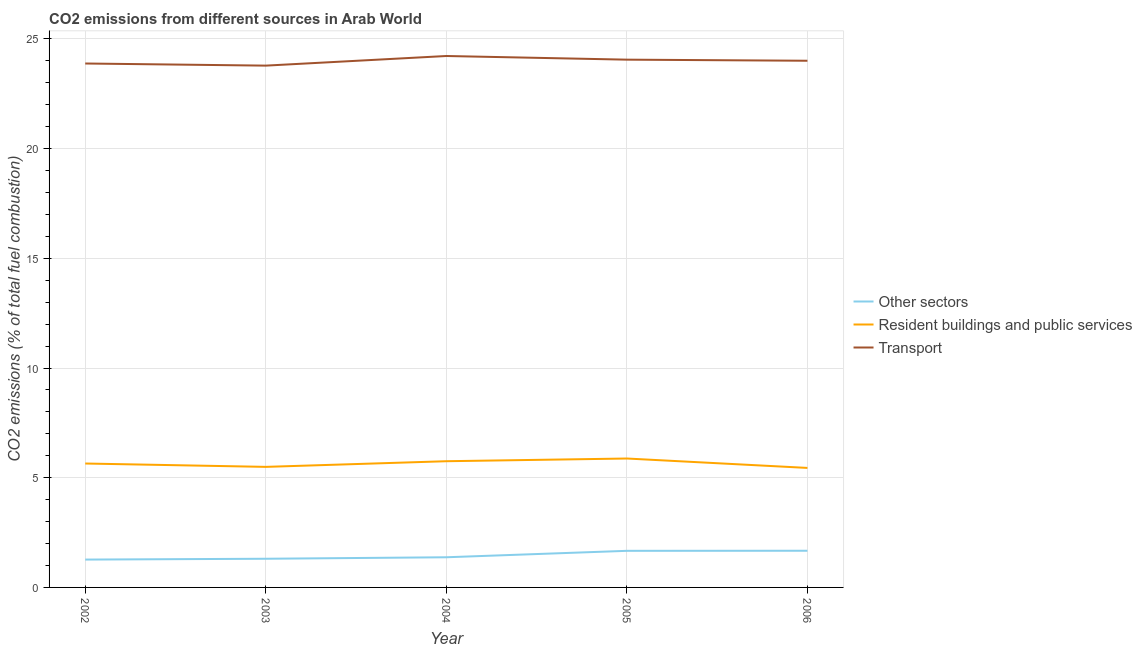How many different coloured lines are there?
Your response must be concise. 3. Does the line corresponding to percentage of co2 emissions from transport intersect with the line corresponding to percentage of co2 emissions from resident buildings and public services?
Your response must be concise. No. Is the number of lines equal to the number of legend labels?
Offer a very short reply. Yes. What is the percentage of co2 emissions from transport in 2002?
Ensure brevity in your answer.  23.88. Across all years, what is the maximum percentage of co2 emissions from resident buildings and public services?
Provide a short and direct response. 5.88. Across all years, what is the minimum percentage of co2 emissions from transport?
Give a very brief answer. 23.79. What is the total percentage of co2 emissions from other sectors in the graph?
Your answer should be very brief. 7.29. What is the difference between the percentage of co2 emissions from transport in 2003 and that in 2004?
Provide a short and direct response. -0.44. What is the difference between the percentage of co2 emissions from resident buildings and public services in 2006 and the percentage of co2 emissions from other sectors in 2004?
Your answer should be very brief. 4.07. What is the average percentage of co2 emissions from resident buildings and public services per year?
Ensure brevity in your answer.  5.64. In the year 2003, what is the difference between the percentage of co2 emissions from transport and percentage of co2 emissions from resident buildings and public services?
Your response must be concise. 18.29. In how many years, is the percentage of co2 emissions from transport greater than 10 %?
Your response must be concise. 5. What is the ratio of the percentage of co2 emissions from other sectors in 2005 to that in 2006?
Your answer should be compact. 1. What is the difference between the highest and the second highest percentage of co2 emissions from other sectors?
Your answer should be compact. 0. What is the difference between the highest and the lowest percentage of co2 emissions from other sectors?
Keep it short and to the point. 0.4. In how many years, is the percentage of co2 emissions from other sectors greater than the average percentage of co2 emissions from other sectors taken over all years?
Your answer should be very brief. 2. Is the sum of the percentage of co2 emissions from other sectors in 2004 and 2005 greater than the maximum percentage of co2 emissions from resident buildings and public services across all years?
Ensure brevity in your answer.  No. Is it the case that in every year, the sum of the percentage of co2 emissions from other sectors and percentage of co2 emissions from resident buildings and public services is greater than the percentage of co2 emissions from transport?
Offer a terse response. No. Does the percentage of co2 emissions from other sectors monotonically increase over the years?
Ensure brevity in your answer.  Yes. Is the percentage of co2 emissions from resident buildings and public services strictly greater than the percentage of co2 emissions from other sectors over the years?
Keep it short and to the point. Yes. Is the percentage of co2 emissions from transport strictly less than the percentage of co2 emissions from other sectors over the years?
Keep it short and to the point. No. How many lines are there?
Provide a short and direct response. 3. How many years are there in the graph?
Give a very brief answer. 5. What is the difference between two consecutive major ticks on the Y-axis?
Provide a succinct answer. 5. Are the values on the major ticks of Y-axis written in scientific E-notation?
Your answer should be compact. No. Does the graph contain any zero values?
Keep it short and to the point. No. Does the graph contain grids?
Make the answer very short. Yes. How many legend labels are there?
Offer a terse response. 3. How are the legend labels stacked?
Your answer should be compact. Vertical. What is the title of the graph?
Your answer should be very brief. CO2 emissions from different sources in Arab World. What is the label or title of the X-axis?
Your answer should be compact. Year. What is the label or title of the Y-axis?
Your response must be concise. CO2 emissions (% of total fuel combustion). What is the CO2 emissions (% of total fuel combustion) of Other sectors in 2002?
Offer a very short reply. 1.27. What is the CO2 emissions (% of total fuel combustion) of Resident buildings and public services in 2002?
Ensure brevity in your answer.  5.65. What is the CO2 emissions (% of total fuel combustion) of Transport in 2002?
Offer a terse response. 23.88. What is the CO2 emissions (% of total fuel combustion) in Other sectors in 2003?
Provide a succinct answer. 1.31. What is the CO2 emissions (% of total fuel combustion) in Resident buildings and public services in 2003?
Your answer should be very brief. 5.5. What is the CO2 emissions (% of total fuel combustion) in Transport in 2003?
Make the answer very short. 23.79. What is the CO2 emissions (% of total fuel combustion) of Other sectors in 2004?
Your response must be concise. 1.38. What is the CO2 emissions (% of total fuel combustion) in Resident buildings and public services in 2004?
Offer a very short reply. 5.75. What is the CO2 emissions (% of total fuel combustion) in Transport in 2004?
Offer a terse response. 24.22. What is the CO2 emissions (% of total fuel combustion) in Other sectors in 2005?
Give a very brief answer. 1.67. What is the CO2 emissions (% of total fuel combustion) of Resident buildings and public services in 2005?
Ensure brevity in your answer.  5.88. What is the CO2 emissions (% of total fuel combustion) of Transport in 2005?
Give a very brief answer. 24.06. What is the CO2 emissions (% of total fuel combustion) in Other sectors in 2006?
Ensure brevity in your answer.  1.67. What is the CO2 emissions (% of total fuel combustion) in Resident buildings and public services in 2006?
Give a very brief answer. 5.45. What is the CO2 emissions (% of total fuel combustion) of Transport in 2006?
Your response must be concise. 24.01. Across all years, what is the maximum CO2 emissions (% of total fuel combustion) of Other sectors?
Your answer should be very brief. 1.67. Across all years, what is the maximum CO2 emissions (% of total fuel combustion) in Resident buildings and public services?
Provide a short and direct response. 5.88. Across all years, what is the maximum CO2 emissions (% of total fuel combustion) of Transport?
Your response must be concise. 24.22. Across all years, what is the minimum CO2 emissions (% of total fuel combustion) in Other sectors?
Offer a very short reply. 1.27. Across all years, what is the minimum CO2 emissions (% of total fuel combustion) in Resident buildings and public services?
Provide a succinct answer. 5.45. Across all years, what is the minimum CO2 emissions (% of total fuel combustion) in Transport?
Provide a succinct answer. 23.79. What is the total CO2 emissions (% of total fuel combustion) of Other sectors in the graph?
Your answer should be compact. 7.29. What is the total CO2 emissions (% of total fuel combustion) in Resident buildings and public services in the graph?
Keep it short and to the point. 28.22. What is the total CO2 emissions (% of total fuel combustion) of Transport in the graph?
Offer a terse response. 119.96. What is the difference between the CO2 emissions (% of total fuel combustion) of Other sectors in 2002 and that in 2003?
Your answer should be very brief. -0.04. What is the difference between the CO2 emissions (% of total fuel combustion) in Resident buildings and public services in 2002 and that in 2003?
Offer a terse response. 0.15. What is the difference between the CO2 emissions (% of total fuel combustion) of Transport in 2002 and that in 2003?
Provide a succinct answer. 0.1. What is the difference between the CO2 emissions (% of total fuel combustion) of Other sectors in 2002 and that in 2004?
Make the answer very short. -0.11. What is the difference between the CO2 emissions (% of total fuel combustion) of Resident buildings and public services in 2002 and that in 2004?
Ensure brevity in your answer.  -0.1. What is the difference between the CO2 emissions (% of total fuel combustion) in Transport in 2002 and that in 2004?
Give a very brief answer. -0.34. What is the difference between the CO2 emissions (% of total fuel combustion) in Other sectors in 2002 and that in 2005?
Provide a short and direct response. -0.4. What is the difference between the CO2 emissions (% of total fuel combustion) of Resident buildings and public services in 2002 and that in 2005?
Provide a short and direct response. -0.23. What is the difference between the CO2 emissions (% of total fuel combustion) of Transport in 2002 and that in 2005?
Give a very brief answer. -0.18. What is the difference between the CO2 emissions (% of total fuel combustion) of Other sectors in 2002 and that in 2006?
Keep it short and to the point. -0.4. What is the difference between the CO2 emissions (% of total fuel combustion) of Resident buildings and public services in 2002 and that in 2006?
Your answer should be very brief. 0.2. What is the difference between the CO2 emissions (% of total fuel combustion) in Transport in 2002 and that in 2006?
Offer a very short reply. -0.13. What is the difference between the CO2 emissions (% of total fuel combustion) in Other sectors in 2003 and that in 2004?
Ensure brevity in your answer.  -0.07. What is the difference between the CO2 emissions (% of total fuel combustion) of Resident buildings and public services in 2003 and that in 2004?
Offer a terse response. -0.26. What is the difference between the CO2 emissions (% of total fuel combustion) in Transport in 2003 and that in 2004?
Ensure brevity in your answer.  -0.44. What is the difference between the CO2 emissions (% of total fuel combustion) of Other sectors in 2003 and that in 2005?
Ensure brevity in your answer.  -0.36. What is the difference between the CO2 emissions (% of total fuel combustion) in Resident buildings and public services in 2003 and that in 2005?
Ensure brevity in your answer.  -0.38. What is the difference between the CO2 emissions (% of total fuel combustion) in Transport in 2003 and that in 2005?
Your answer should be very brief. -0.27. What is the difference between the CO2 emissions (% of total fuel combustion) in Other sectors in 2003 and that in 2006?
Your response must be concise. -0.36. What is the difference between the CO2 emissions (% of total fuel combustion) in Resident buildings and public services in 2003 and that in 2006?
Offer a very short reply. 0.05. What is the difference between the CO2 emissions (% of total fuel combustion) of Transport in 2003 and that in 2006?
Your response must be concise. -0.22. What is the difference between the CO2 emissions (% of total fuel combustion) of Other sectors in 2004 and that in 2005?
Provide a succinct answer. -0.29. What is the difference between the CO2 emissions (% of total fuel combustion) in Resident buildings and public services in 2004 and that in 2005?
Give a very brief answer. -0.12. What is the difference between the CO2 emissions (% of total fuel combustion) in Transport in 2004 and that in 2005?
Your response must be concise. 0.17. What is the difference between the CO2 emissions (% of total fuel combustion) of Other sectors in 2004 and that in 2006?
Provide a short and direct response. -0.3. What is the difference between the CO2 emissions (% of total fuel combustion) in Resident buildings and public services in 2004 and that in 2006?
Your answer should be very brief. 0.31. What is the difference between the CO2 emissions (% of total fuel combustion) in Transport in 2004 and that in 2006?
Make the answer very short. 0.22. What is the difference between the CO2 emissions (% of total fuel combustion) in Other sectors in 2005 and that in 2006?
Provide a succinct answer. -0. What is the difference between the CO2 emissions (% of total fuel combustion) of Resident buildings and public services in 2005 and that in 2006?
Your answer should be very brief. 0.43. What is the difference between the CO2 emissions (% of total fuel combustion) in Transport in 2005 and that in 2006?
Give a very brief answer. 0.05. What is the difference between the CO2 emissions (% of total fuel combustion) of Other sectors in 2002 and the CO2 emissions (% of total fuel combustion) of Resident buildings and public services in 2003?
Offer a terse response. -4.23. What is the difference between the CO2 emissions (% of total fuel combustion) of Other sectors in 2002 and the CO2 emissions (% of total fuel combustion) of Transport in 2003?
Keep it short and to the point. -22.52. What is the difference between the CO2 emissions (% of total fuel combustion) in Resident buildings and public services in 2002 and the CO2 emissions (% of total fuel combustion) in Transport in 2003?
Give a very brief answer. -18.14. What is the difference between the CO2 emissions (% of total fuel combustion) in Other sectors in 2002 and the CO2 emissions (% of total fuel combustion) in Resident buildings and public services in 2004?
Your response must be concise. -4.48. What is the difference between the CO2 emissions (% of total fuel combustion) in Other sectors in 2002 and the CO2 emissions (% of total fuel combustion) in Transport in 2004?
Make the answer very short. -22.95. What is the difference between the CO2 emissions (% of total fuel combustion) in Resident buildings and public services in 2002 and the CO2 emissions (% of total fuel combustion) in Transport in 2004?
Ensure brevity in your answer.  -18.58. What is the difference between the CO2 emissions (% of total fuel combustion) of Other sectors in 2002 and the CO2 emissions (% of total fuel combustion) of Resident buildings and public services in 2005?
Provide a succinct answer. -4.61. What is the difference between the CO2 emissions (% of total fuel combustion) of Other sectors in 2002 and the CO2 emissions (% of total fuel combustion) of Transport in 2005?
Keep it short and to the point. -22.79. What is the difference between the CO2 emissions (% of total fuel combustion) in Resident buildings and public services in 2002 and the CO2 emissions (% of total fuel combustion) in Transport in 2005?
Offer a very short reply. -18.41. What is the difference between the CO2 emissions (% of total fuel combustion) in Other sectors in 2002 and the CO2 emissions (% of total fuel combustion) in Resident buildings and public services in 2006?
Provide a short and direct response. -4.18. What is the difference between the CO2 emissions (% of total fuel combustion) of Other sectors in 2002 and the CO2 emissions (% of total fuel combustion) of Transport in 2006?
Your answer should be compact. -22.74. What is the difference between the CO2 emissions (% of total fuel combustion) in Resident buildings and public services in 2002 and the CO2 emissions (% of total fuel combustion) in Transport in 2006?
Keep it short and to the point. -18.36. What is the difference between the CO2 emissions (% of total fuel combustion) in Other sectors in 2003 and the CO2 emissions (% of total fuel combustion) in Resident buildings and public services in 2004?
Offer a very short reply. -4.45. What is the difference between the CO2 emissions (% of total fuel combustion) in Other sectors in 2003 and the CO2 emissions (% of total fuel combustion) in Transport in 2004?
Your answer should be very brief. -22.92. What is the difference between the CO2 emissions (% of total fuel combustion) in Resident buildings and public services in 2003 and the CO2 emissions (% of total fuel combustion) in Transport in 2004?
Keep it short and to the point. -18.73. What is the difference between the CO2 emissions (% of total fuel combustion) of Other sectors in 2003 and the CO2 emissions (% of total fuel combustion) of Resident buildings and public services in 2005?
Ensure brevity in your answer.  -4.57. What is the difference between the CO2 emissions (% of total fuel combustion) in Other sectors in 2003 and the CO2 emissions (% of total fuel combustion) in Transport in 2005?
Make the answer very short. -22.75. What is the difference between the CO2 emissions (% of total fuel combustion) in Resident buildings and public services in 2003 and the CO2 emissions (% of total fuel combustion) in Transport in 2005?
Offer a very short reply. -18.56. What is the difference between the CO2 emissions (% of total fuel combustion) of Other sectors in 2003 and the CO2 emissions (% of total fuel combustion) of Resident buildings and public services in 2006?
Your answer should be very brief. -4.14. What is the difference between the CO2 emissions (% of total fuel combustion) of Other sectors in 2003 and the CO2 emissions (% of total fuel combustion) of Transport in 2006?
Offer a very short reply. -22.7. What is the difference between the CO2 emissions (% of total fuel combustion) in Resident buildings and public services in 2003 and the CO2 emissions (% of total fuel combustion) in Transport in 2006?
Your answer should be very brief. -18.51. What is the difference between the CO2 emissions (% of total fuel combustion) in Other sectors in 2004 and the CO2 emissions (% of total fuel combustion) in Resident buildings and public services in 2005?
Give a very brief answer. -4.5. What is the difference between the CO2 emissions (% of total fuel combustion) of Other sectors in 2004 and the CO2 emissions (% of total fuel combustion) of Transport in 2005?
Your answer should be compact. -22.68. What is the difference between the CO2 emissions (% of total fuel combustion) of Resident buildings and public services in 2004 and the CO2 emissions (% of total fuel combustion) of Transport in 2005?
Your answer should be very brief. -18.3. What is the difference between the CO2 emissions (% of total fuel combustion) of Other sectors in 2004 and the CO2 emissions (% of total fuel combustion) of Resident buildings and public services in 2006?
Offer a terse response. -4.07. What is the difference between the CO2 emissions (% of total fuel combustion) of Other sectors in 2004 and the CO2 emissions (% of total fuel combustion) of Transport in 2006?
Provide a short and direct response. -22.63. What is the difference between the CO2 emissions (% of total fuel combustion) in Resident buildings and public services in 2004 and the CO2 emissions (% of total fuel combustion) in Transport in 2006?
Provide a succinct answer. -18.25. What is the difference between the CO2 emissions (% of total fuel combustion) of Other sectors in 2005 and the CO2 emissions (% of total fuel combustion) of Resident buildings and public services in 2006?
Make the answer very short. -3.78. What is the difference between the CO2 emissions (% of total fuel combustion) in Other sectors in 2005 and the CO2 emissions (% of total fuel combustion) in Transport in 2006?
Keep it short and to the point. -22.34. What is the difference between the CO2 emissions (% of total fuel combustion) in Resident buildings and public services in 2005 and the CO2 emissions (% of total fuel combustion) in Transport in 2006?
Make the answer very short. -18.13. What is the average CO2 emissions (% of total fuel combustion) in Other sectors per year?
Your answer should be compact. 1.46. What is the average CO2 emissions (% of total fuel combustion) in Resident buildings and public services per year?
Provide a succinct answer. 5.64. What is the average CO2 emissions (% of total fuel combustion) in Transport per year?
Your response must be concise. 23.99. In the year 2002, what is the difference between the CO2 emissions (% of total fuel combustion) of Other sectors and CO2 emissions (% of total fuel combustion) of Resident buildings and public services?
Offer a terse response. -4.38. In the year 2002, what is the difference between the CO2 emissions (% of total fuel combustion) in Other sectors and CO2 emissions (% of total fuel combustion) in Transport?
Your answer should be compact. -22.61. In the year 2002, what is the difference between the CO2 emissions (% of total fuel combustion) of Resident buildings and public services and CO2 emissions (% of total fuel combustion) of Transport?
Your answer should be very brief. -18.23. In the year 2003, what is the difference between the CO2 emissions (% of total fuel combustion) in Other sectors and CO2 emissions (% of total fuel combustion) in Resident buildings and public services?
Offer a terse response. -4.19. In the year 2003, what is the difference between the CO2 emissions (% of total fuel combustion) in Other sectors and CO2 emissions (% of total fuel combustion) in Transport?
Your answer should be very brief. -22.48. In the year 2003, what is the difference between the CO2 emissions (% of total fuel combustion) in Resident buildings and public services and CO2 emissions (% of total fuel combustion) in Transport?
Your answer should be compact. -18.29. In the year 2004, what is the difference between the CO2 emissions (% of total fuel combustion) of Other sectors and CO2 emissions (% of total fuel combustion) of Resident buildings and public services?
Ensure brevity in your answer.  -4.38. In the year 2004, what is the difference between the CO2 emissions (% of total fuel combustion) in Other sectors and CO2 emissions (% of total fuel combustion) in Transport?
Your answer should be compact. -22.85. In the year 2004, what is the difference between the CO2 emissions (% of total fuel combustion) of Resident buildings and public services and CO2 emissions (% of total fuel combustion) of Transport?
Offer a very short reply. -18.47. In the year 2005, what is the difference between the CO2 emissions (% of total fuel combustion) in Other sectors and CO2 emissions (% of total fuel combustion) in Resident buildings and public services?
Give a very brief answer. -4.21. In the year 2005, what is the difference between the CO2 emissions (% of total fuel combustion) in Other sectors and CO2 emissions (% of total fuel combustion) in Transport?
Provide a succinct answer. -22.39. In the year 2005, what is the difference between the CO2 emissions (% of total fuel combustion) of Resident buildings and public services and CO2 emissions (% of total fuel combustion) of Transport?
Your answer should be compact. -18.18. In the year 2006, what is the difference between the CO2 emissions (% of total fuel combustion) in Other sectors and CO2 emissions (% of total fuel combustion) in Resident buildings and public services?
Make the answer very short. -3.78. In the year 2006, what is the difference between the CO2 emissions (% of total fuel combustion) in Other sectors and CO2 emissions (% of total fuel combustion) in Transport?
Offer a very short reply. -22.34. In the year 2006, what is the difference between the CO2 emissions (% of total fuel combustion) of Resident buildings and public services and CO2 emissions (% of total fuel combustion) of Transport?
Ensure brevity in your answer.  -18.56. What is the ratio of the CO2 emissions (% of total fuel combustion) in Other sectors in 2002 to that in 2003?
Your answer should be very brief. 0.97. What is the ratio of the CO2 emissions (% of total fuel combustion) of Resident buildings and public services in 2002 to that in 2003?
Keep it short and to the point. 1.03. What is the ratio of the CO2 emissions (% of total fuel combustion) in Transport in 2002 to that in 2003?
Keep it short and to the point. 1. What is the ratio of the CO2 emissions (% of total fuel combustion) of Other sectors in 2002 to that in 2004?
Ensure brevity in your answer.  0.92. What is the ratio of the CO2 emissions (% of total fuel combustion) of Resident buildings and public services in 2002 to that in 2004?
Offer a very short reply. 0.98. What is the ratio of the CO2 emissions (% of total fuel combustion) in Transport in 2002 to that in 2004?
Make the answer very short. 0.99. What is the ratio of the CO2 emissions (% of total fuel combustion) of Other sectors in 2002 to that in 2005?
Offer a terse response. 0.76. What is the ratio of the CO2 emissions (% of total fuel combustion) of Resident buildings and public services in 2002 to that in 2005?
Your response must be concise. 0.96. What is the ratio of the CO2 emissions (% of total fuel combustion) in Other sectors in 2002 to that in 2006?
Keep it short and to the point. 0.76. What is the ratio of the CO2 emissions (% of total fuel combustion) in Resident buildings and public services in 2002 to that in 2006?
Keep it short and to the point. 1.04. What is the ratio of the CO2 emissions (% of total fuel combustion) of Transport in 2002 to that in 2006?
Offer a terse response. 0.99. What is the ratio of the CO2 emissions (% of total fuel combustion) in Other sectors in 2003 to that in 2004?
Keep it short and to the point. 0.95. What is the ratio of the CO2 emissions (% of total fuel combustion) in Resident buildings and public services in 2003 to that in 2004?
Give a very brief answer. 0.96. What is the ratio of the CO2 emissions (% of total fuel combustion) in Transport in 2003 to that in 2004?
Offer a very short reply. 0.98. What is the ratio of the CO2 emissions (% of total fuel combustion) of Other sectors in 2003 to that in 2005?
Offer a terse response. 0.78. What is the ratio of the CO2 emissions (% of total fuel combustion) in Resident buildings and public services in 2003 to that in 2005?
Provide a succinct answer. 0.94. What is the ratio of the CO2 emissions (% of total fuel combustion) of Transport in 2003 to that in 2005?
Provide a succinct answer. 0.99. What is the ratio of the CO2 emissions (% of total fuel combustion) of Other sectors in 2003 to that in 2006?
Make the answer very short. 0.78. What is the ratio of the CO2 emissions (% of total fuel combustion) of Resident buildings and public services in 2003 to that in 2006?
Make the answer very short. 1.01. What is the ratio of the CO2 emissions (% of total fuel combustion) in Transport in 2003 to that in 2006?
Offer a very short reply. 0.99. What is the ratio of the CO2 emissions (% of total fuel combustion) of Other sectors in 2004 to that in 2005?
Provide a short and direct response. 0.82. What is the ratio of the CO2 emissions (% of total fuel combustion) in Transport in 2004 to that in 2005?
Your answer should be very brief. 1.01. What is the ratio of the CO2 emissions (% of total fuel combustion) in Other sectors in 2004 to that in 2006?
Provide a short and direct response. 0.82. What is the ratio of the CO2 emissions (% of total fuel combustion) in Resident buildings and public services in 2004 to that in 2006?
Your answer should be compact. 1.06. What is the ratio of the CO2 emissions (% of total fuel combustion) in Resident buildings and public services in 2005 to that in 2006?
Offer a terse response. 1.08. What is the difference between the highest and the second highest CO2 emissions (% of total fuel combustion) in Other sectors?
Provide a succinct answer. 0. What is the difference between the highest and the second highest CO2 emissions (% of total fuel combustion) of Resident buildings and public services?
Give a very brief answer. 0.12. What is the difference between the highest and the second highest CO2 emissions (% of total fuel combustion) of Transport?
Offer a very short reply. 0.17. What is the difference between the highest and the lowest CO2 emissions (% of total fuel combustion) in Other sectors?
Keep it short and to the point. 0.4. What is the difference between the highest and the lowest CO2 emissions (% of total fuel combustion) of Resident buildings and public services?
Keep it short and to the point. 0.43. What is the difference between the highest and the lowest CO2 emissions (% of total fuel combustion) of Transport?
Your answer should be very brief. 0.44. 